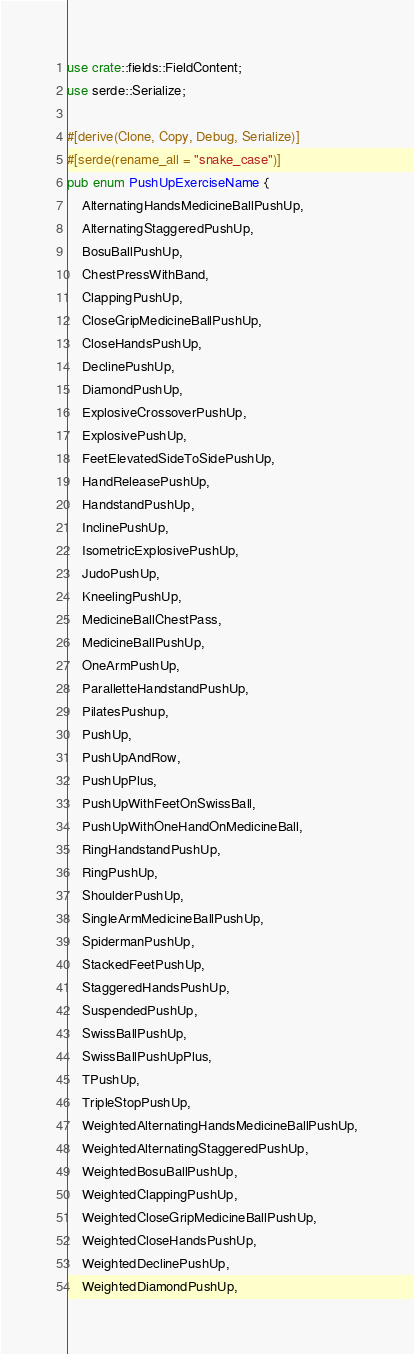<code> <loc_0><loc_0><loc_500><loc_500><_Rust_>use crate::fields::FieldContent;
use serde::Serialize;

#[derive(Clone, Copy, Debug, Serialize)]
#[serde(rename_all = "snake_case")]
pub enum PushUpExerciseName {
    AlternatingHandsMedicineBallPushUp,
    AlternatingStaggeredPushUp,
    BosuBallPushUp,
    ChestPressWithBand,
    ClappingPushUp,
    CloseGripMedicineBallPushUp,
    CloseHandsPushUp,
    DeclinePushUp,
    DiamondPushUp,
    ExplosiveCrossoverPushUp,
    ExplosivePushUp,
    FeetElevatedSideToSidePushUp,
    HandReleasePushUp,
    HandstandPushUp,
    InclinePushUp,
    IsometricExplosivePushUp,
    JudoPushUp,
    KneelingPushUp,
    MedicineBallChestPass,
    MedicineBallPushUp,
    OneArmPushUp,
    ParalletteHandstandPushUp,
    PilatesPushup,
    PushUp,
    PushUpAndRow,
    PushUpPlus,
    PushUpWithFeetOnSwissBall,
    PushUpWithOneHandOnMedicineBall,
    RingHandstandPushUp,
    RingPushUp,
    ShoulderPushUp,
    SingleArmMedicineBallPushUp,
    SpidermanPushUp,
    StackedFeetPushUp,
    StaggeredHandsPushUp,
    SuspendedPushUp,
    SwissBallPushUp,
    SwissBallPushUpPlus,
    TPushUp,
    TripleStopPushUp,
    WeightedAlternatingHandsMedicineBallPushUp,
    WeightedAlternatingStaggeredPushUp,
    WeightedBosuBallPushUp,
    WeightedClappingPushUp,
    WeightedCloseGripMedicineBallPushUp,
    WeightedCloseHandsPushUp,
    WeightedDeclinePushUp,
    WeightedDiamondPushUp,</code> 